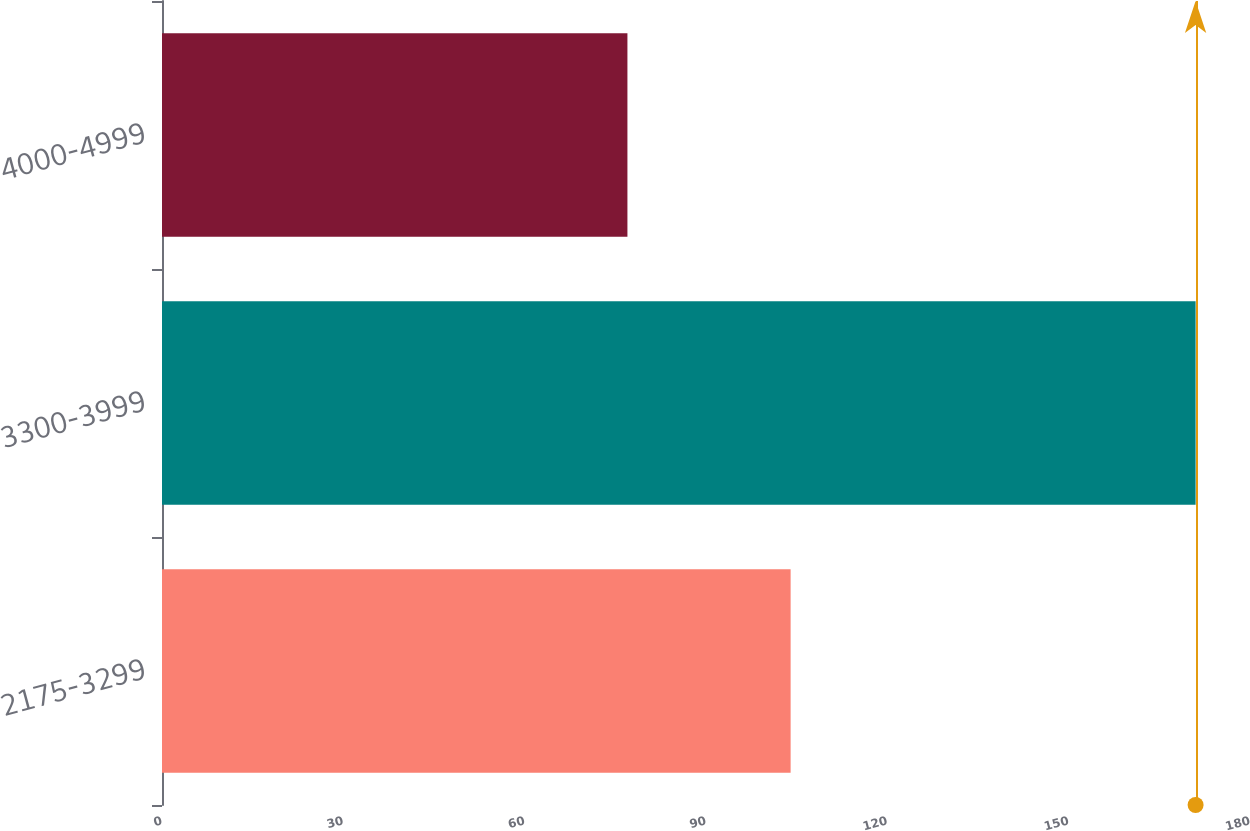Convert chart to OTSL. <chart><loc_0><loc_0><loc_500><loc_500><bar_chart><fcel>2175-3299<fcel>3300-3999<fcel>4000-4999<nl><fcel>104<fcel>171<fcel>77<nl></chart> 